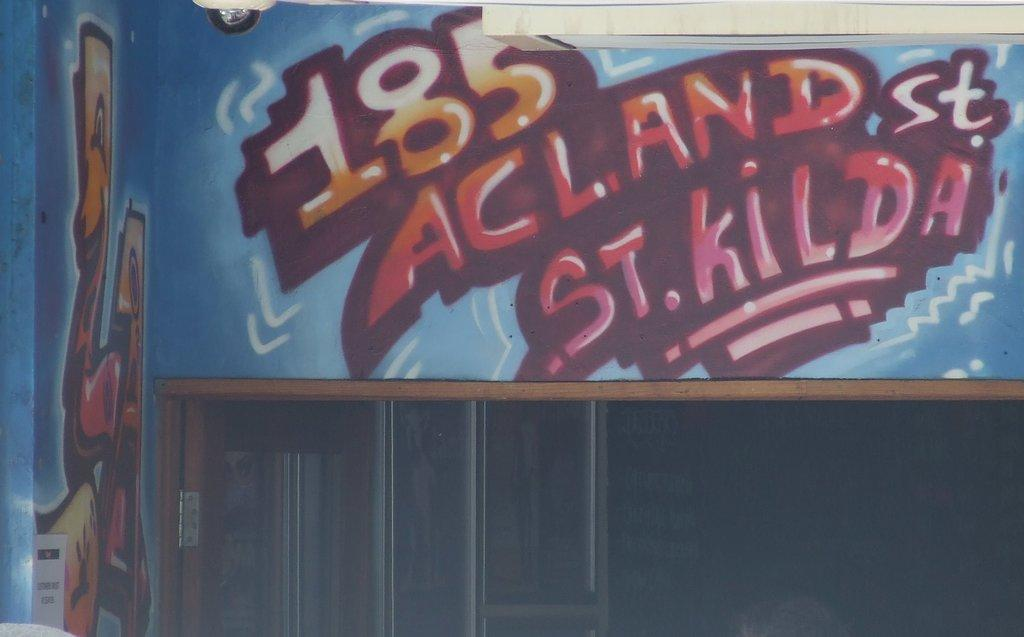<image>
Summarize the visual content of the image. Graffiti on a wall displaying the address as 185 Acland St. St. Kilda 